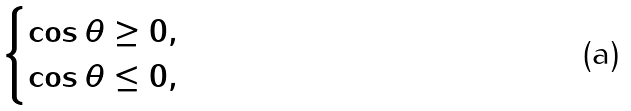<formula> <loc_0><loc_0><loc_500><loc_500>\begin{cases} \cos \theta \geq 0 , \\ \cos \theta \leq 0 , \end{cases}</formula> 